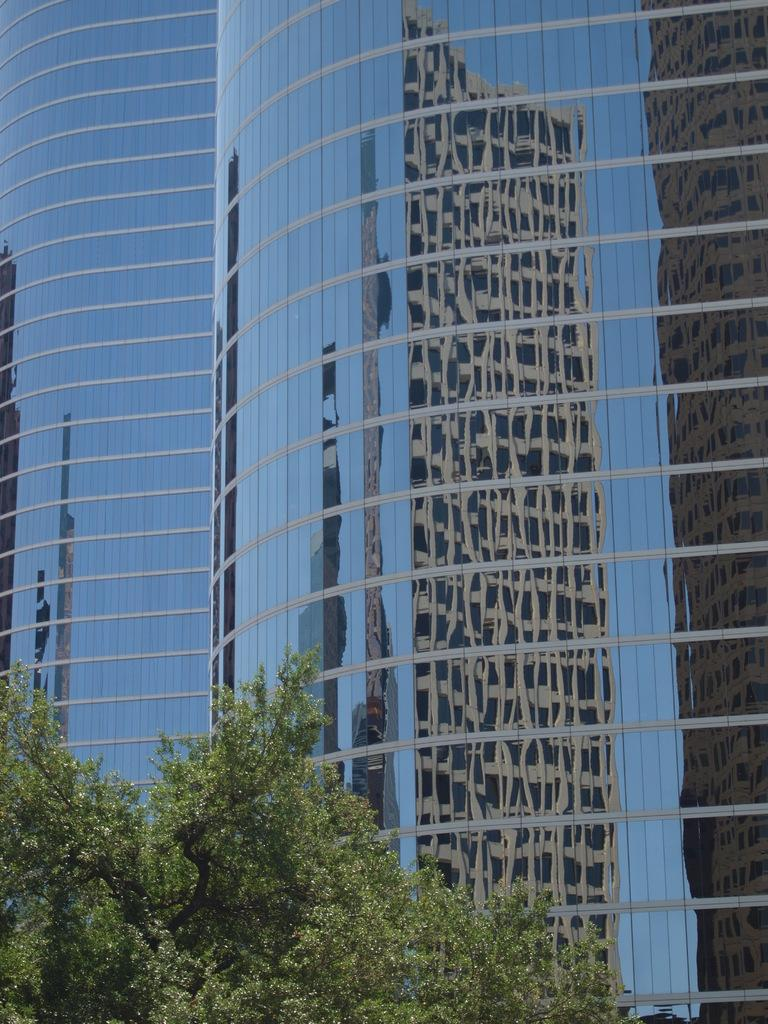What type of buildings can be seen in the image? There are glass buildings in the image. What natural element is present in the image? There is a tree in the image. What brand of toothpaste is advertised on the tree in the image? There is no toothpaste or advertisement present on the tree in the image. How does the tree contribute to the holiday atmosphere in the image? The image does not depict a holiday scene, and therefore the tree does not contribute to a holiday atmosphere. 